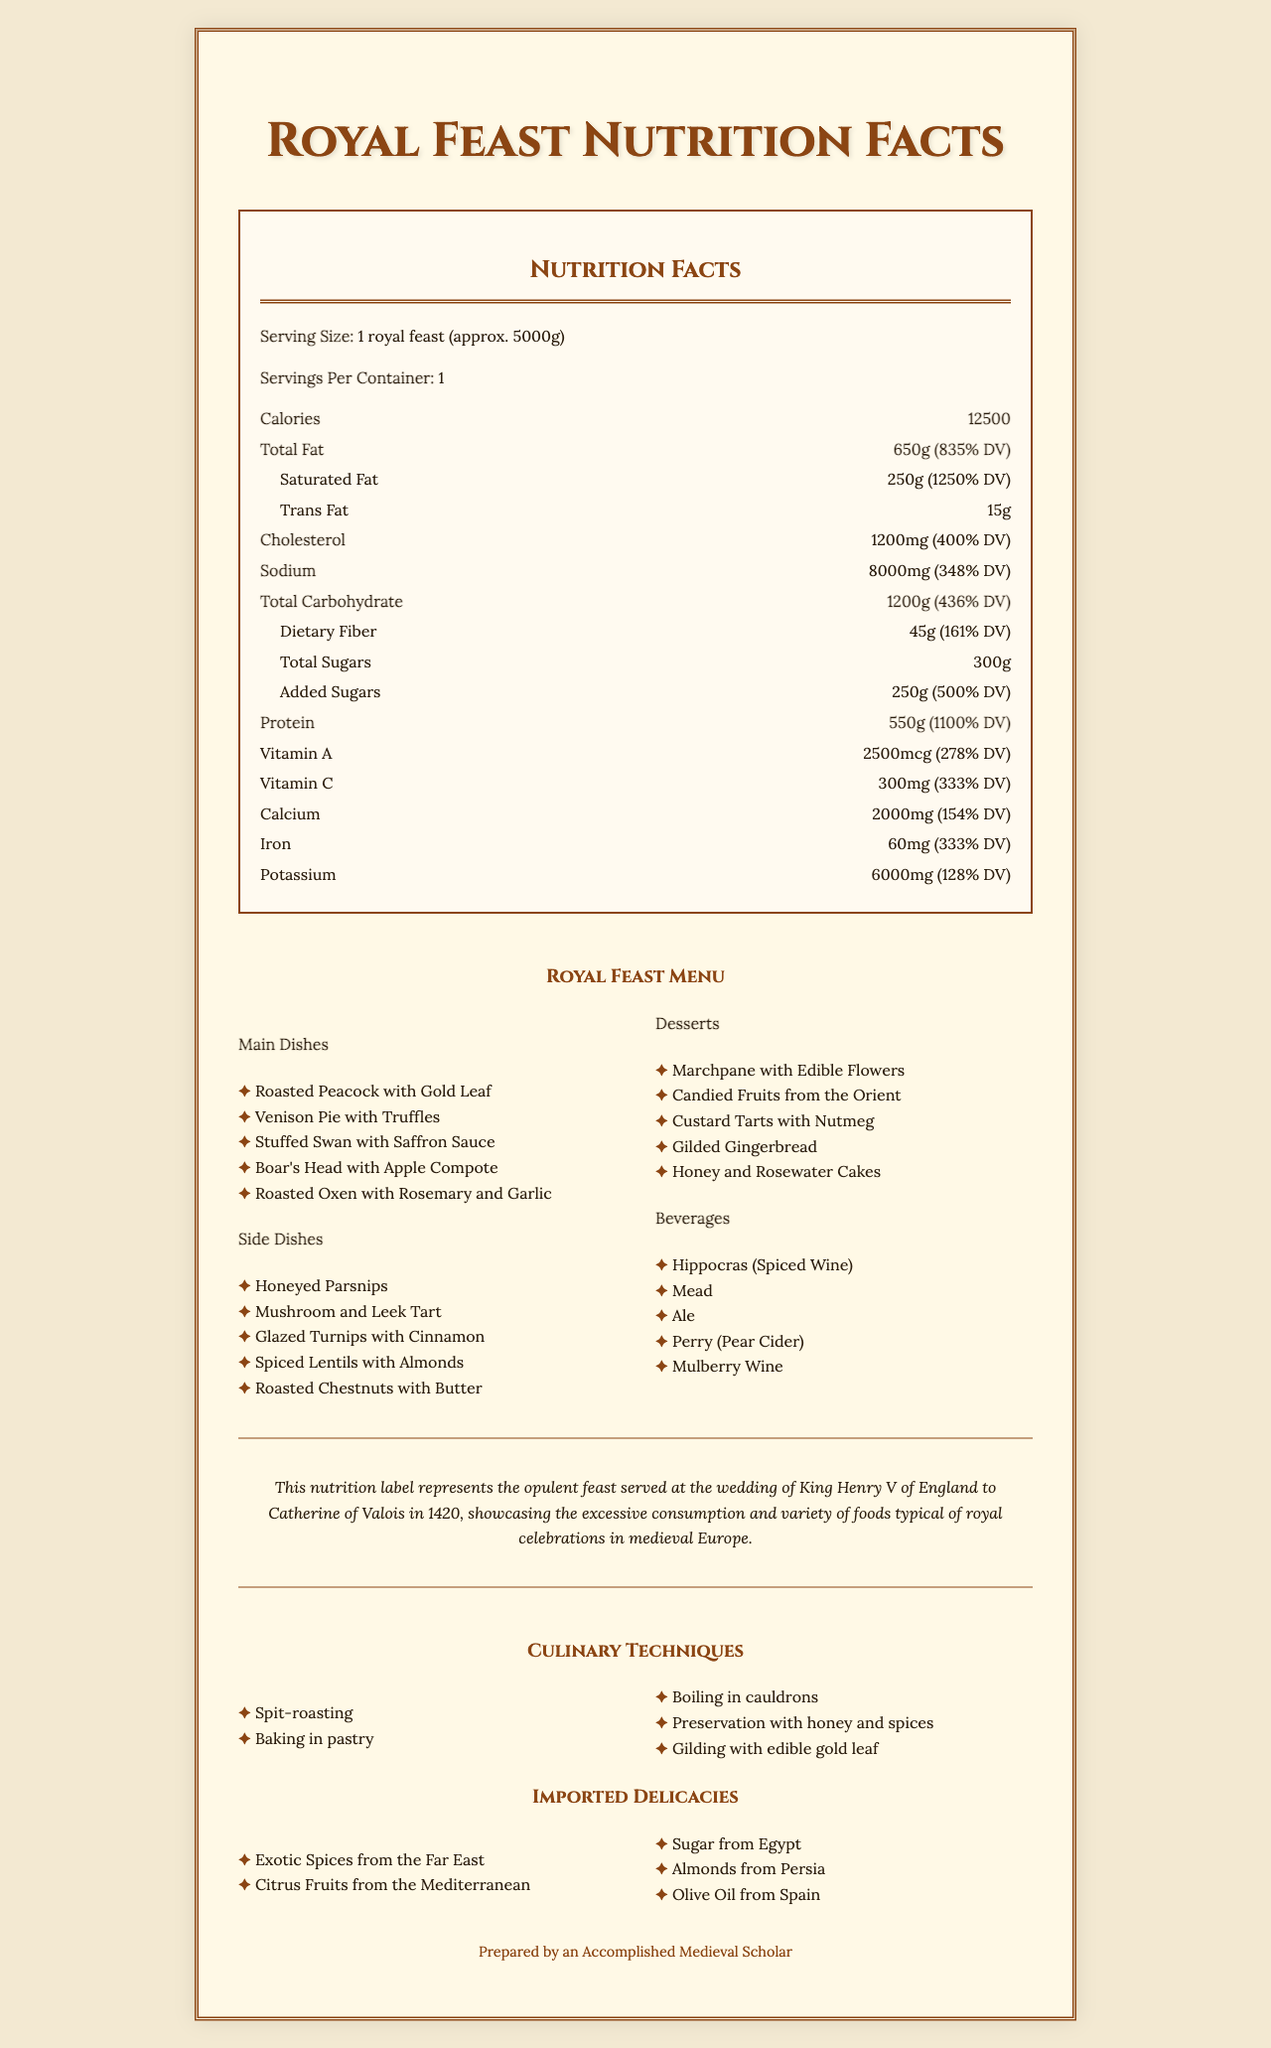what is the serving size of the royal feast? The serving size is explicitly stated as "1 royal feast (approx. 5000g)".
Answer: 1 royal feast (approx. 5000g) how many servings are in one container? The document states there is 1 serving per container.
Answer: 1 how many calories are there in the royal feast? The document lists the total calories as 12500.
Answer: 12500 what is the total fat content and its daily value? The label shows Total Fat as 650g, with a daily value of 835%.
Answer: 650g (835% DV) how much protein is in the feast? Protein content is listed as 550g, and this represents 1100% of the daily value.
Answer: 550g (1100% DV) how many culinary techniques are listed? A. 3 B. 5 C. 7 D. 9 There are 5 culinary techniques listed: Spit-roasting, Baking in pastry, Boiling in cauldrons, Preservation with honey and spices, and Gilding with edible gold leaf.
Answer: B which of the following is not an imported delicacy? A. Spices from the Far East B. Sugars from Egypt C. Thames River Fish D. Citrus Fruits from the Mediterranean C is not listed in the imported delicacies section, while the other options are.
Answer: C did the feast include beverages? The document lists beverages under a section that includes Hippocras (Spiced Wine), Mead, Ale, Perry (Pear Cider), and Mulberry Wine.
Answer: Yes summarize the main content of the document. The nutrition label provides comprehensive details about a royal feast, including nutritional values, menu items, historical and culinary context, and imported delicacies, reflecting the lavish nature of royal celebrations in medieval Europe.
Answer: This document is a nutrition facts label for a royal wedding banquet, detailing the opulent variety and nutritional content of foods served. It includes data such as serving size, total calories, and breakdowns of fats, cholesterol, sodium, carbohydrates, and protein. Additionally, it highlights the extravagant menu items, historical context of a medieval feast, culinary techniques, and imported delicacies. what was the exact date of the wedding banquet for which this nutrition label provides information? The document mentions the context of King Henry V's wedding to Catherine of Valois but does not specify the exact date within the provided text. The year 1420 is mentioned for additional context.
Answer: Not enough information 